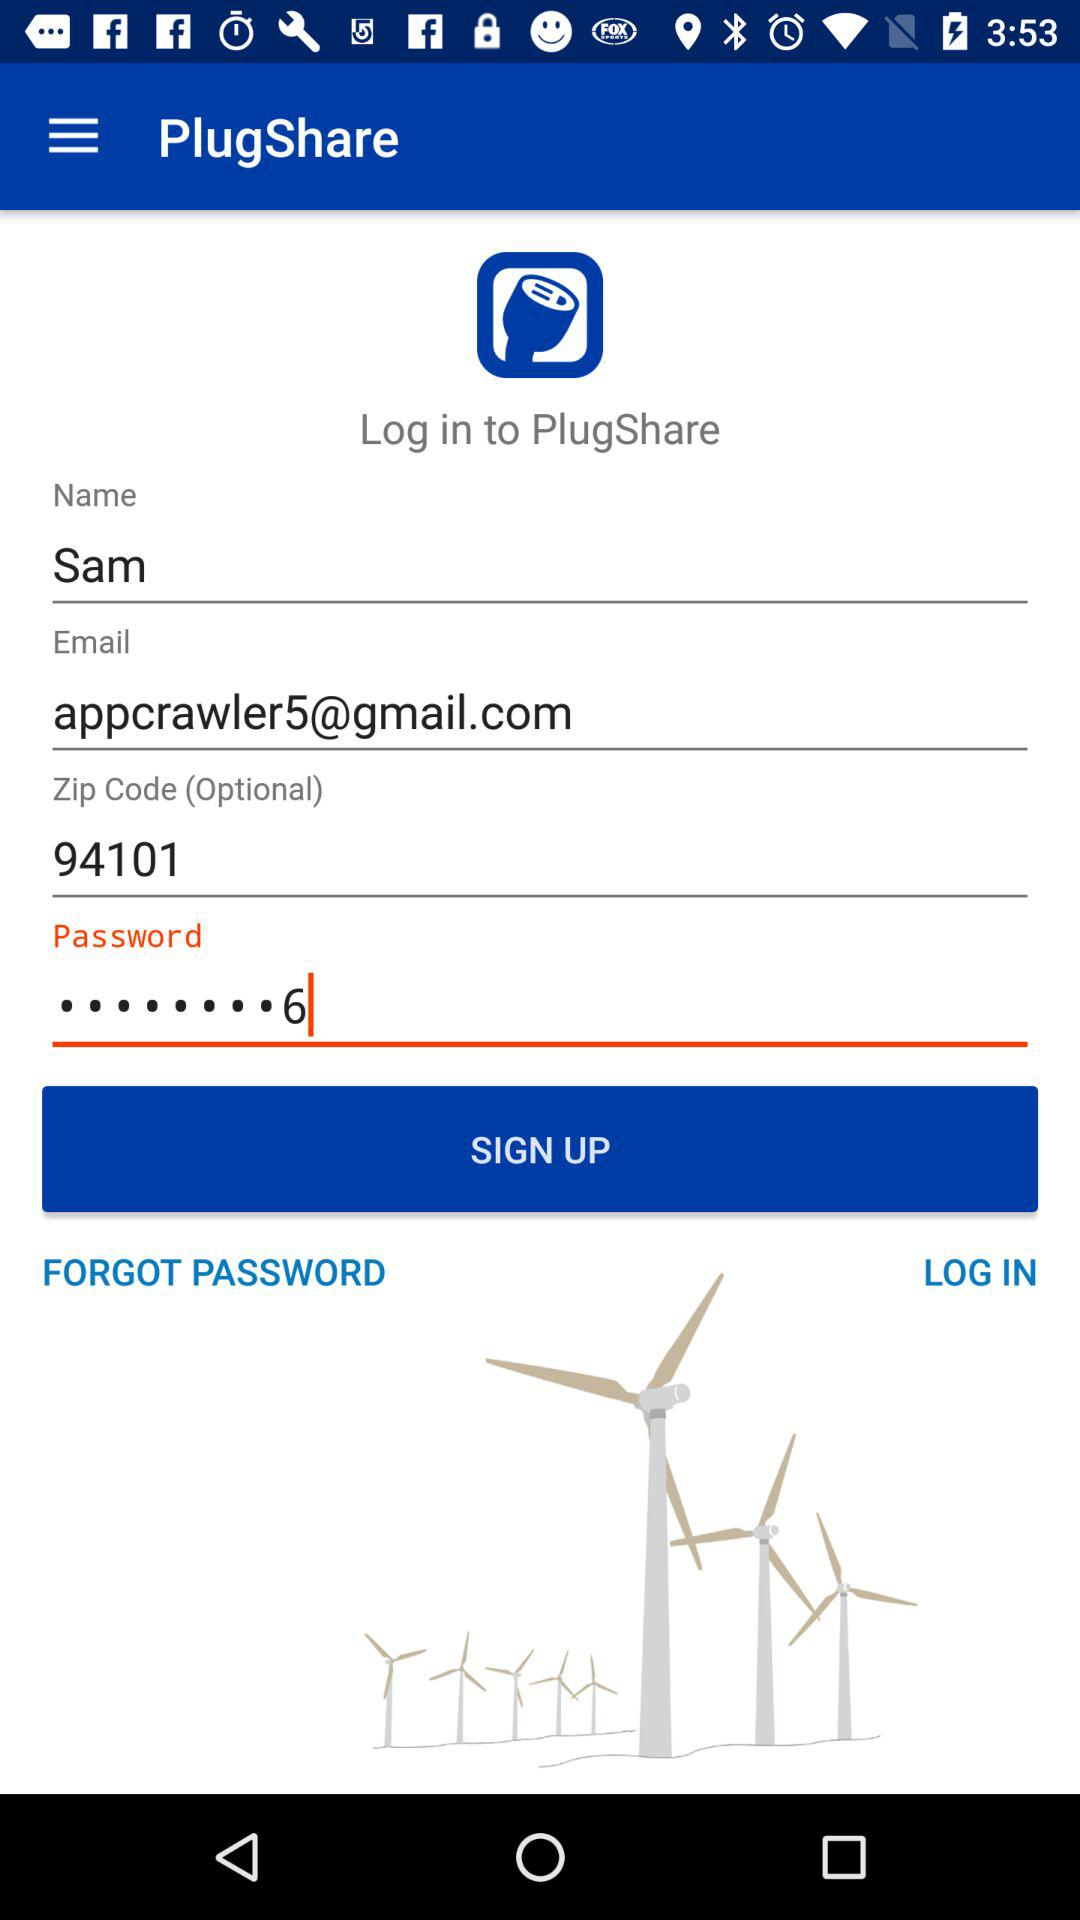What email address is used? The email address used is appcrawler5@gmail.com. 